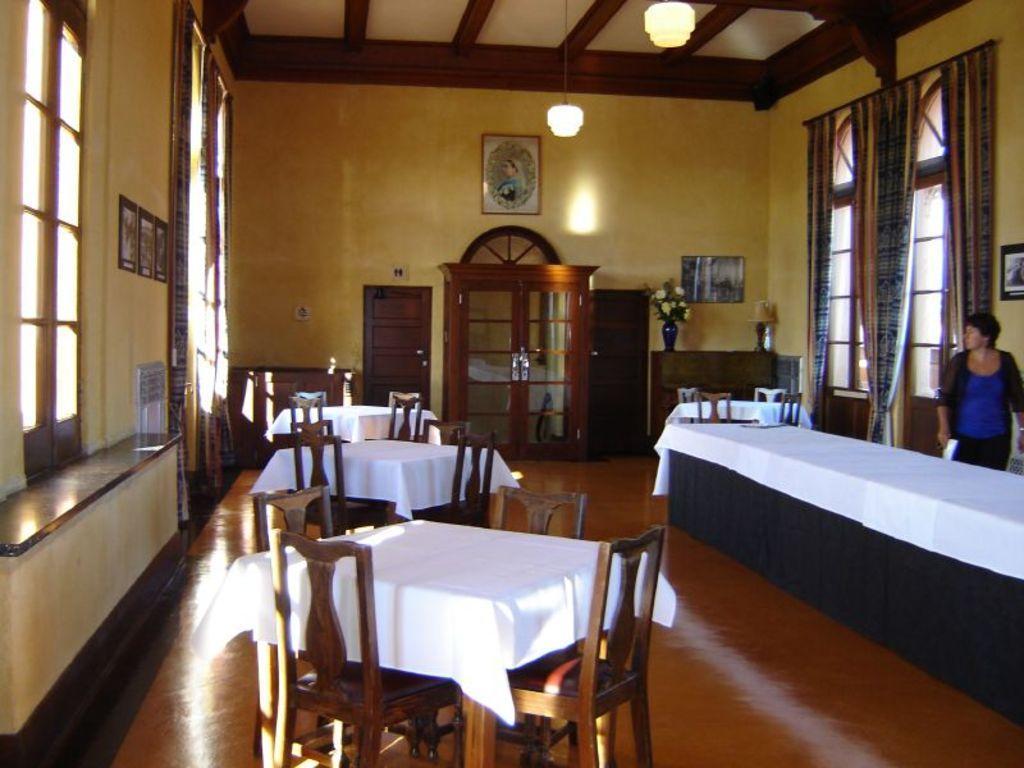Can you describe this image briefly? In this picture there is a dining table on the right side of the image and there are other tables with chairs on the left side of the image, there are windows on the right and left side of the image, there is a rack in the center of the image, there is a lady who is standing on the right side of the image. 